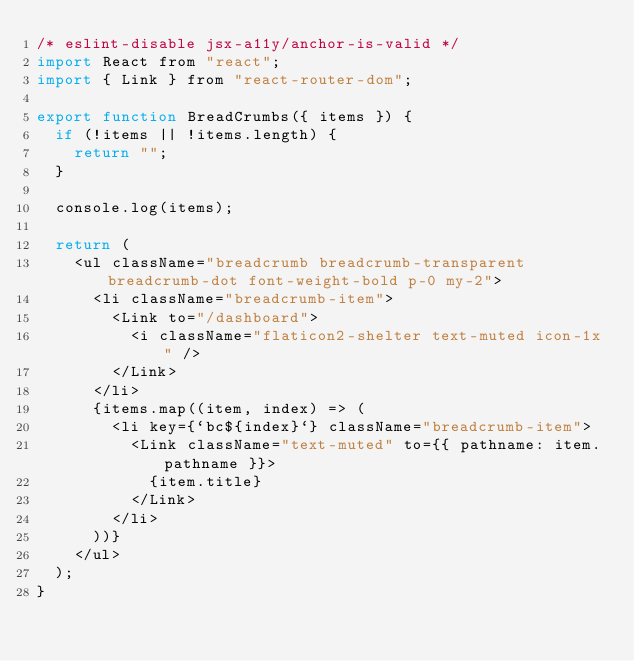<code> <loc_0><loc_0><loc_500><loc_500><_JavaScript_>/* eslint-disable jsx-a11y/anchor-is-valid */
import React from "react";
import { Link } from "react-router-dom";

export function BreadCrumbs({ items }) {
  if (!items || !items.length) {
    return "";
  }

  console.log(items);

  return (
    <ul className="breadcrumb breadcrumb-transparent breadcrumb-dot font-weight-bold p-0 my-2">
      <li className="breadcrumb-item">
        <Link to="/dashboard">
          <i className="flaticon2-shelter text-muted icon-1x" />
        </Link>
      </li>
      {items.map((item, index) => (
        <li key={`bc${index}`} className="breadcrumb-item">
          <Link className="text-muted" to={{ pathname: item.pathname }}>
            {item.title}
          </Link>
        </li>
      ))}
    </ul>
  );
}
</code> 